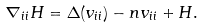<formula> <loc_0><loc_0><loc_500><loc_500>\nabla _ { i i } H = \Delta ( v _ { i i } ) - n v _ { i i } + H .</formula> 